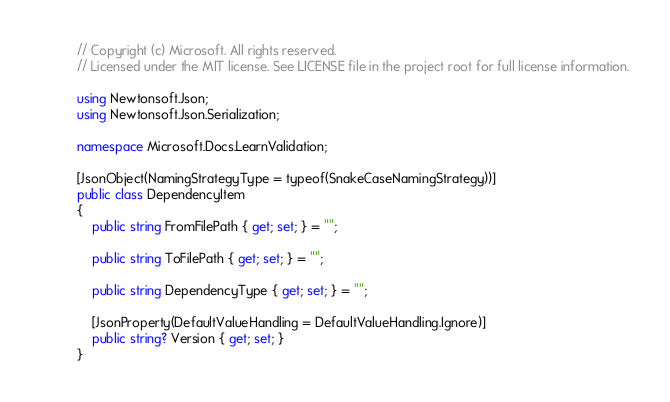Convert code to text. <code><loc_0><loc_0><loc_500><loc_500><_C#_>// Copyright (c) Microsoft. All rights reserved.
// Licensed under the MIT license. See LICENSE file in the project root for full license information.

using Newtonsoft.Json;
using Newtonsoft.Json.Serialization;

namespace Microsoft.Docs.LearnValidation;

[JsonObject(NamingStrategyType = typeof(SnakeCaseNamingStrategy))]
public class DependencyItem
{
    public string FromFilePath { get; set; } = "";

    public string ToFilePath { get; set; } = "";

    public string DependencyType { get; set; } = "";

    [JsonProperty(DefaultValueHandling = DefaultValueHandling.Ignore)]
    public string? Version { get; set; }
}
</code> 